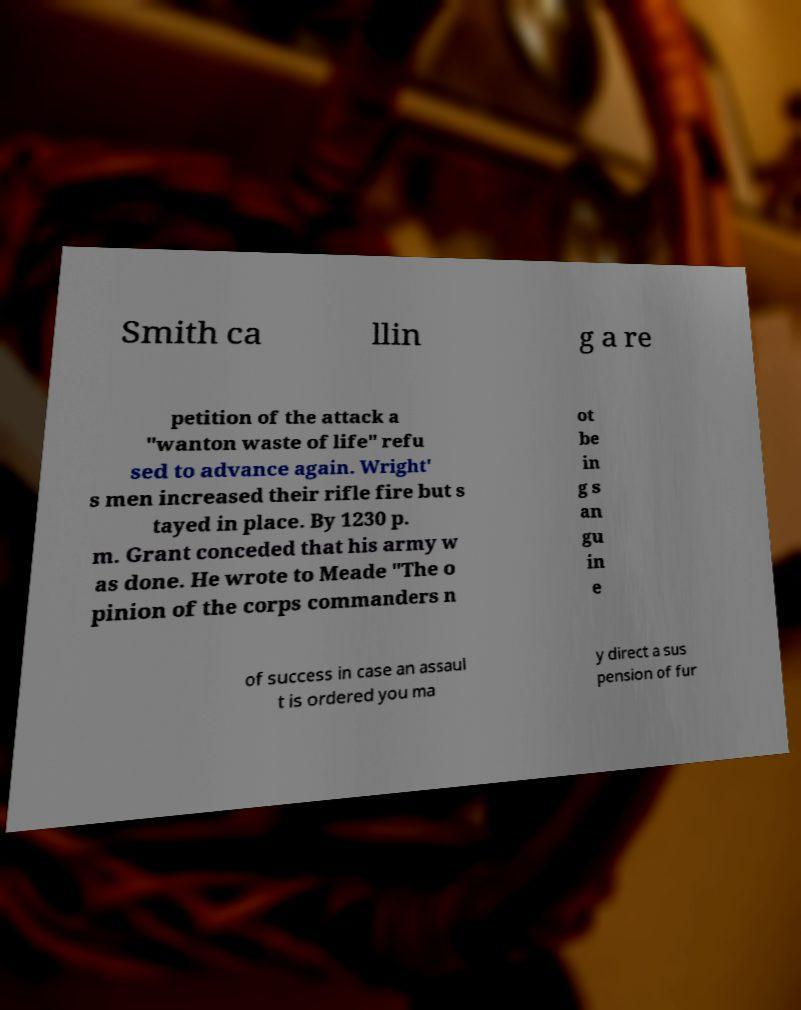Could you extract and type out the text from this image? Smith ca llin g a re petition of the attack a "wanton waste of life" refu sed to advance again. Wright' s men increased their rifle fire but s tayed in place. By 1230 p. m. Grant conceded that his army w as done. He wrote to Meade "The o pinion of the corps commanders n ot be in g s an gu in e of success in case an assaul t is ordered you ma y direct a sus pension of fur 